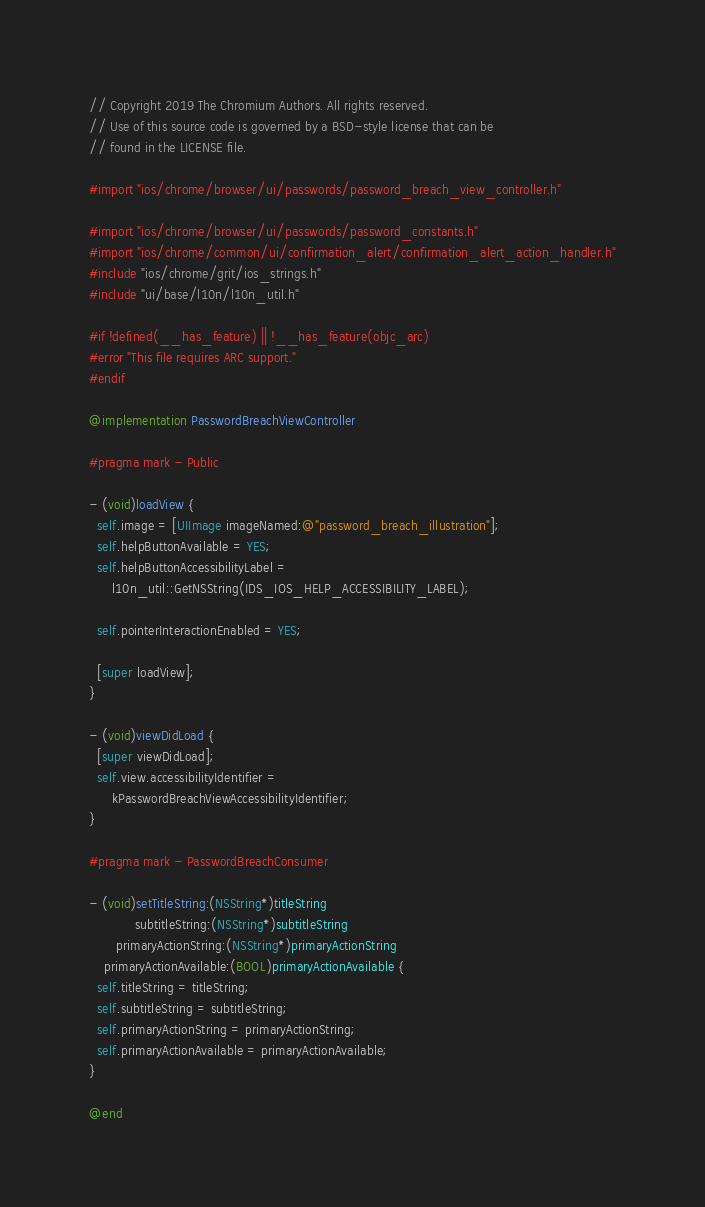Convert code to text. <code><loc_0><loc_0><loc_500><loc_500><_ObjectiveC_>// Copyright 2019 The Chromium Authors. All rights reserved.
// Use of this source code is governed by a BSD-style license that can be
// found in the LICENSE file.

#import "ios/chrome/browser/ui/passwords/password_breach_view_controller.h"

#import "ios/chrome/browser/ui/passwords/password_constants.h"
#import "ios/chrome/common/ui/confirmation_alert/confirmation_alert_action_handler.h"
#include "ios/chrome/grit/ios_strings.h"
#include "ui/base/l10n/l10n_util.h"

#if !defined(__has_feature) || !__has_feature(objc_arc)
#error "This file requires ARC support."
#endif

@implementation PasswordBreachViewController

#pragma mark - Public

- (void)loadView {
  self.image = [UIImage imageNamed:@"password_breach_illustration"];
  self.helpButtonAvailable = YES;
  self.helpButtonAccessibilityLabel =
      l10n_util::GetNSString(IDS_IOS_HELP_ACCESSIBILITY_LABEL);

  self.pointerInteractionEnabled = YES;

  [super loadView];
}

- (void)viewDidLoad {
  [super viewDidLoad];
  self.view.accessibilityIdentifier =
      kPasswordBreachViewAccessibilityIdentifier;
}

#pragma mark - PasswordBreachConsumer

- (void)setTitleString:(NSString*)titleString
            subtitleString:(NSString*)subtitleString
       primaryActionString:(NSString*)primaryActionString
    primaryActionAvailable:(BOOL)primaryActionAvailable {
  self.titleString = titleString;
  self.subtitleString = subtitleString;
  self.primaryActionString = primaryActionString;
  self.primaryActionAvailable = primaryActionAvailable;
}

@end
</code> 